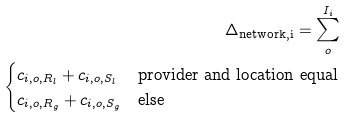<formula> <loc_0><loc_0><loc_500><loc_500>\Delta _ { \text {network,i} } = \sum ^ { I _ { i } } _ { o } \\ \begin{cases} c _ { i , o , R _ { l } } + c _ { i , o , S _ { l } } & \text {provider and location equal} \\ c _ { i , o , R _ { g } } + c _ { i , o , S _ { g } } & \text {else} \\ \end{cases}</formula> 